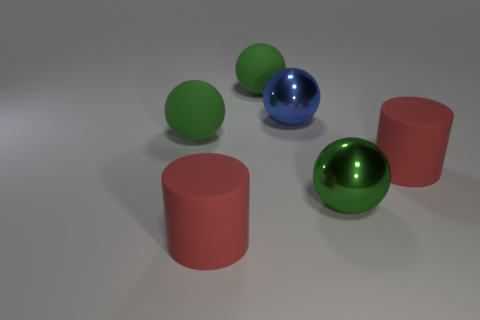There is a sphere that is in front of the blue shiny object and behind the green metallic sphere; what color is it?
Your response must be concise. Green. What number of big cylinders have the same material as the large blue object?
Provide a succinct answer. 0. What number of large red cylinders are there?
Offer a terse response. 2. Does the blue object have the same size as the red object that is on the right side of the blue metal thing?
Your answer should be very brief. Yes. What material is the large red cylinder that is left of the red cylinder to the right of the blue shiny thing?
Your answer should be very brief. Rubber. There is a shiny object in front of the large red thing on the right side of the large shiny object that is on the right side of the large blue object; what size is it?
Your answer should be very brief. Large. Do the green metallic thing and the big red object that is in front of the green metal sphere have the same shape?
Offer a very short reply. No. What is the large blue ball made of?
Give a very brief answer. Metal. How many shiny objects are either big red objects or balls?
Your answer should be compact. 2. Is the number of big green matte spheres on the right side of the green metal thing less than the number of red matte cylinders that are in front of the big blue thing?
Your response must be concise. Yes. 